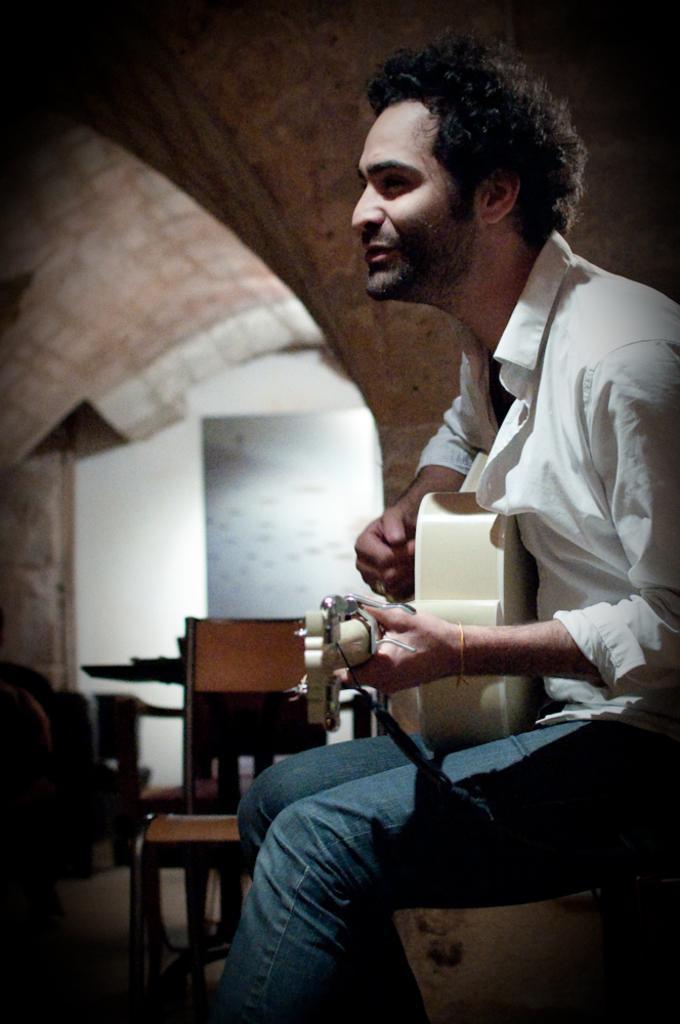Can you describe this image briefly? This picture seems to be clicked inside the room. On the right there is a man wearing white color shirt, sitting and playing guitar. On the left we can see a chair and some other objects are placed on the ground. In the background we can see the wall, roof and some other objects. 